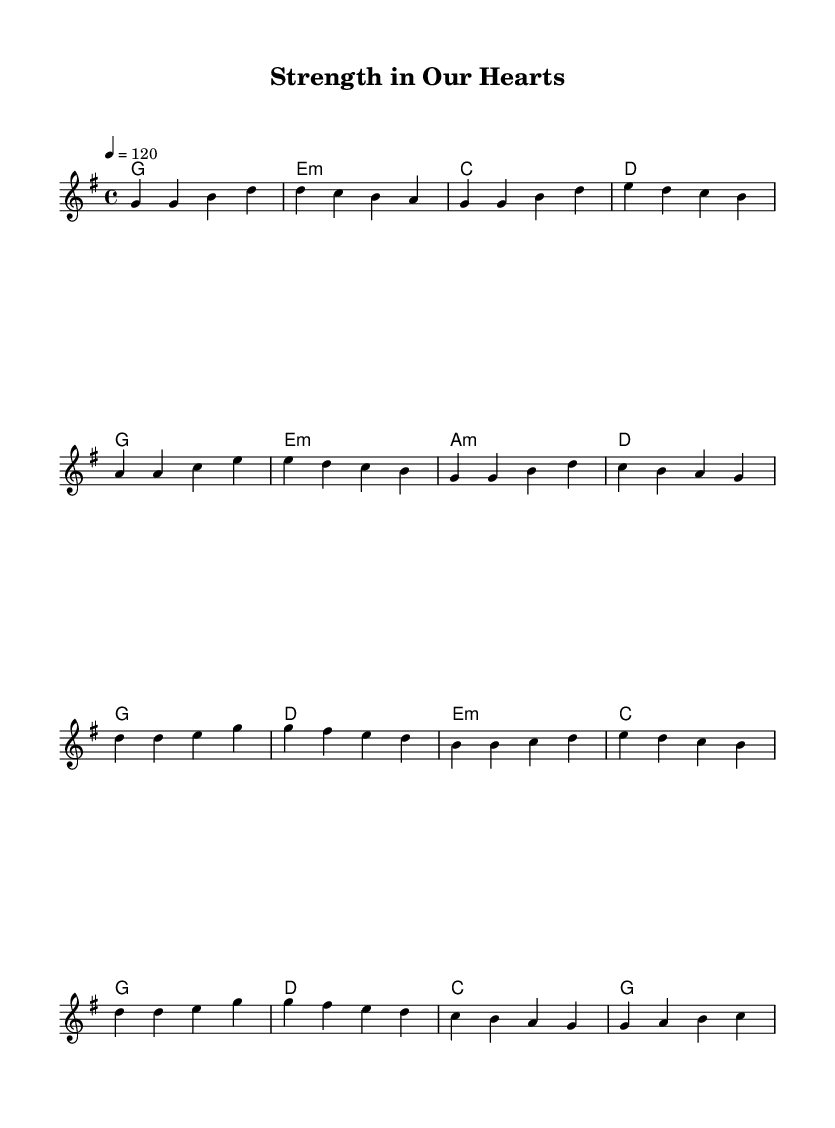What is the key signature of this music? The key signature is G major, indicated by an F# in the music.
Answer: G major What is the time signature of this music? The time signature is 4/4, as indicated by the notation at the beginning of the piece.
Answer: 4/4 What is the tempo marking for this piece? The tempo marking is 120 beats per minute, shown above the staff in the music.
Answer: 120 How many measures are in the verse section? There are 8 measures in the verse section, as determined by counting each group of notes separated by vertical lines.
Answer: 8 What is the first chord in the chorus? The first chord in the chorus is G major, which is the first chord shown at the start of the chorus section.
Answer: G major How many different chords are used in the verse? There are 4 different chords in the verse: G, E minor, C, and D, as identified from the chord symbols written above the staff.
Answer: 4 What theme does this music primarily convey? The theme of the music is resilience and hope, reflecting the uplifting nature of the song as indicated by the title and overall structure.
Answer: Resilience and hope 